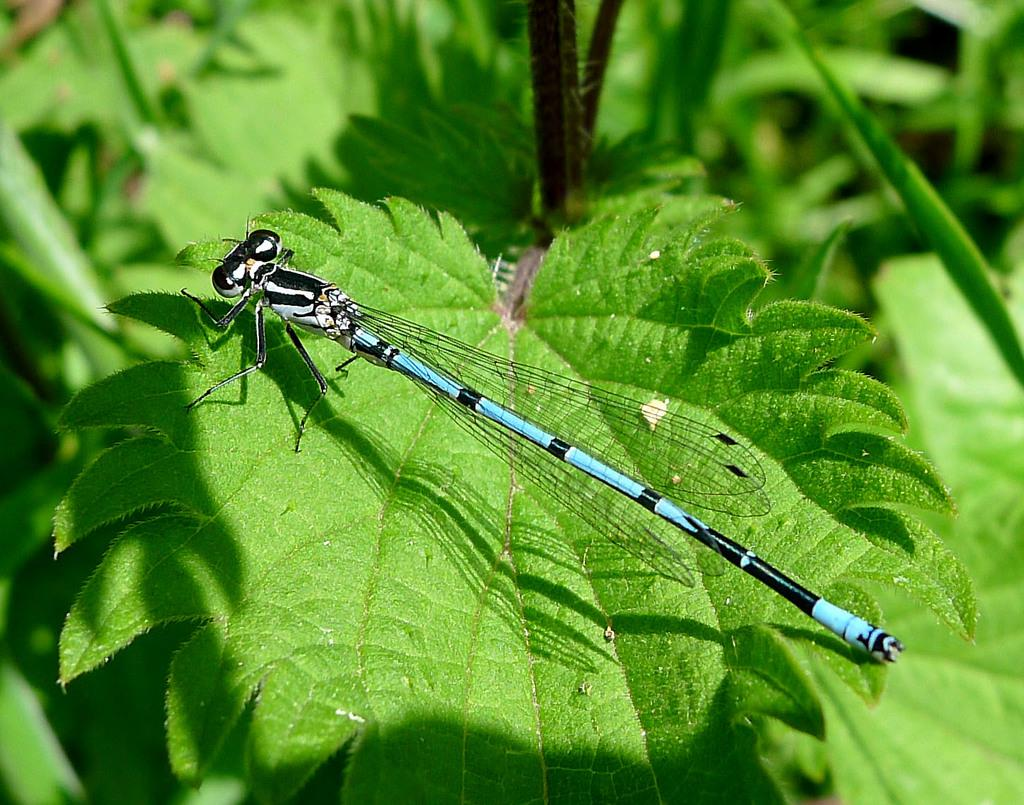What is present in the image? There is an insect in the image. Where is the insect located? The insect is on a leaf. What colors can be seen on the insect? The insect has black, white, and blue colors. What color are the leaves in the image? The leaves are green. What type of coat is the insect wearing in the image? There is no coat present in the image, as insects do not wear clothing. 